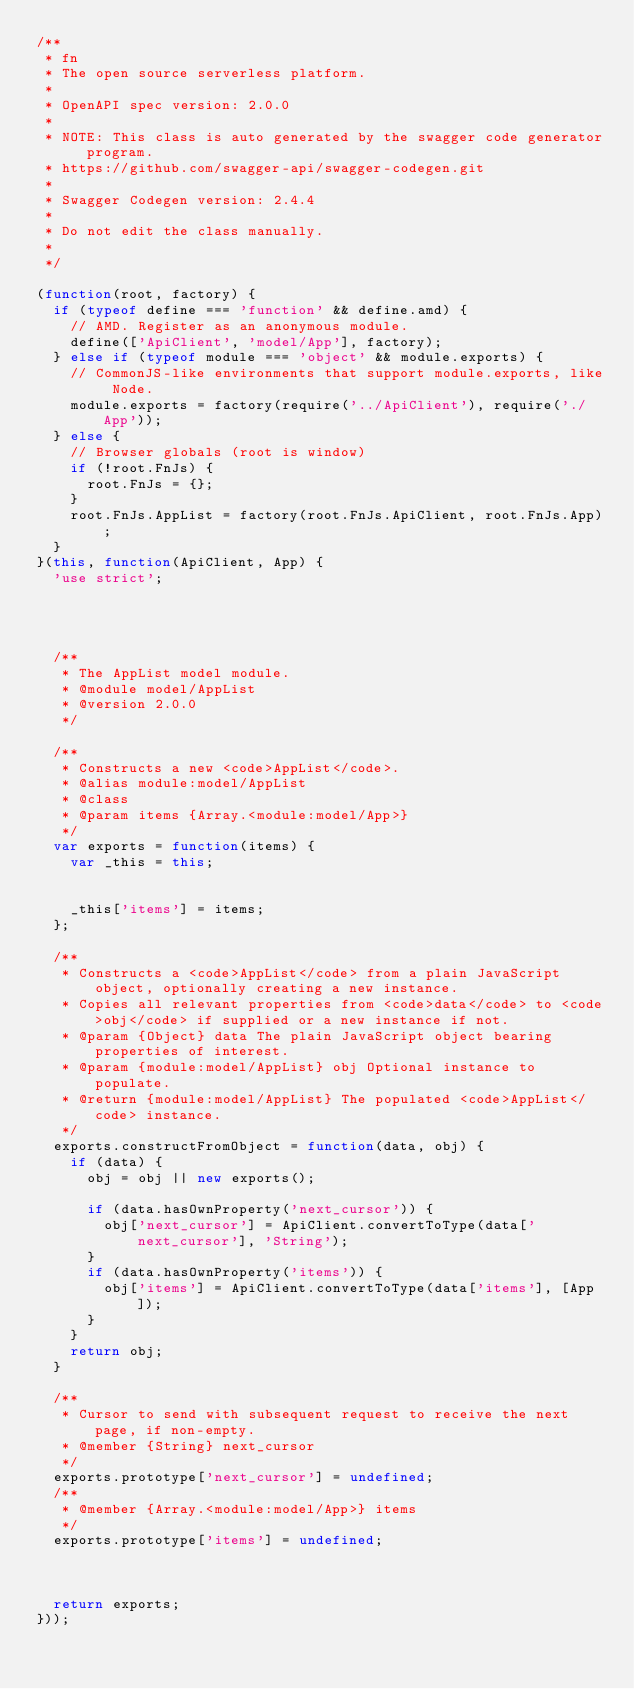<code> <loc_0><loc_0><loc_500><loc_500><_JavaScript_>/**
 * fn
 * The open source serverless platform.
 *
 * OpenAPI spec version: 2.0.0
 *
 * NOTE: This class is auto generated by the swagger code generator program.
 * https://github.com/swagger-api/swagger-codegen.git
 *
 * Swagger Codegen version: 2.4.4
 *
 * Do not edit the class manually.
 *
 */

(function(root, factory) {
  if (typeof define === 'function' && define.amd) {
    // AMD. Register as an anonymous module.
    define(['ApiClient', 'model/App'], factory);
  } else if (typeof module === 'object' && module.exports) {
    // CommonJS-like environments that support module.exports, like Node.
    module.exports = factory(require('../ApiClient'), require('./App'));
  } else {
    // Browser globals (root is window)
    if (!root.FnJs) {
      root.FnJs = {};
    }
    root.FnJs.AppList = factory(root.FnJs.ApiClient, root.FnJs.App);
  }
}(this, function(ApiClient, App) {
  'use strict';




  /**
   * The AppList model module.
   * @module model/AppList
   * @version 2.0.0
   */

  /**
   * Constructs a new <code>AppList</code>.
   * @alias module:model/AppList
   * @class
   * @param items {Array.<module:model/App>} 
   */
  var exports = function(items) {
    var _this = this;


    _this['items'] = items;
  };

  /**
   * Constructs a <code>AppList</code> from a plain JavaScript object, optionally creating a new instance.
   * Copies all relevant properties from <code>data</code> to <code>obj</code> if supplied or a new instance if not.
   * @param {Object} data The plain JavaScript object bearing properties of interest.
   * @param {module:model/AppList} obj Optional instance to populate.
   * @return {module:model/AppList} The populated <code>AppList</code> instance.
   */
  exports.constructFromObject = function(data, obj) {
    if (data) {
      obj = obj || new exports();

      if (data.hasOwnProperty('next_cursor')) {
        obj['next_cursor'] = ApiClient.convertToType(data['next_cursor'], 'String');
      }
      if (data.hasOwnProperty('items')) {
        obj['items'] = ApiClient.convertToType(data['items'], [App]);
      }
    }
    return obj;
  }

  /**
   * Cursor to send with subsequent request to receive the next page, if non-empty.
   * @member {String} next_cursor
   */
  exports.prototype['next_cursor'] = undefined;
  /**
   * @member {Array.<module:model/App>} items
   */
  exports.prototype['items'] = undefined;



  return exports;
}));


</code> 